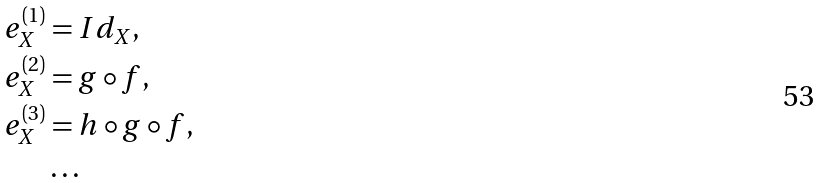Convert formula to latex. <formula><loc_0><loc_0><loc_500><loc_500>e _ { X } ^ { \left ( 1 \right ) } & = I d _ { X } , \\ e _ { X } ^ { \left ( 2 \right ) } & = g \circ f , \\ e _ { X } ^ { \left ( 3 \right ) } & = h \circ g \circ f , \\ & \dots</formula> 